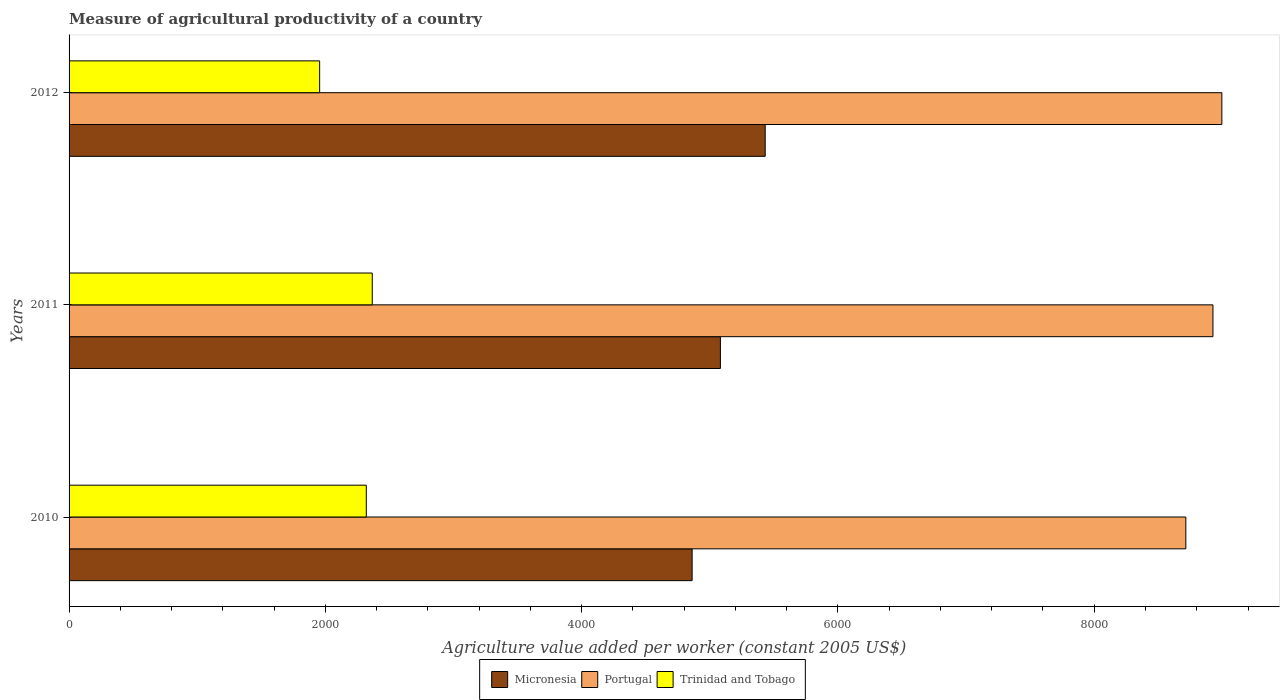How many groups of bars are there?
Your answer should be compact. 3. Are the number of bars on each tick of the Y-axis equal?
Your answer should be compact. Yes. How many bars are there on the 2nd tick from the bottom?
Your response must be concise. 3. What is the label of the 2nd group of bars from the top?
Give a very brief answer. 2011. In how many cases, is the number of bars for a given year not equal to the number of legend labels?
Offer a very short reply. 0. What is the measure of agricultural productivity in Trinidad and Tobago in 2011?
Ensure brevity in your answer.  2365.97. Across all years, what is the maximum measure of agricultural productivity in Portugal?
Ensure brevity in your answer.  8996.02. Across all years, what is the minimum measure of agricultural productivity in Micronesia?
Ensure brevity in your answer.  4862.14. What is the total measure of agricultural productivity in Portugal in the graph?
Provide a succinct answer. 2.66e+04. What is the difference between the measure of agricultural productivity in Trinidad and Tobago in 2010 and that in 2011?
Your response must be concise. -46.55. What is the difference between the measure of agricultural productivity in Trinidad and Tobago in 2010 and the measure of agricultural productivity in Portugal in 2011?
Give a very brief answer. -6607.09. What is the average measure of agricultural productivity in Micronesia per year?
Your response must be concise. 5125.77. In the year 2012, what is the difference between the measure of agricultural productivity in Trinidad and Tobago and measure of agricultural productivity in Portugal?
Your answer should be compact. -7040.59. In how many years, is the measure of agricultural productivity in Micronesia greater than 1200 US$?
Your answer should be compact. 3. What is the ratio of the measure of agricultural productivity in Portugal in 2011 to that in 2012?
Offer a very short reply. 0.99. Is the difference between the measure of agricultural productivity in Trinidad and Tobago in 2011 and 2012 greater than the difference between the measure of agricultural productivity in Portugal in 2011 and 2012?
Provide a succinct answer. Yes. What is the difference between the highest and the second highest measure of agricultural productivity in Portugal?
Make the answer very short. 69.5. What is the difference between the highest and the lowest measure of agricultural productivity in Micronesia?
Make the answer very short. 570.29. Is the sum of the measure of agricultural productivity in Micronesia in 2011 and 2012 greater than the maximum measure of agricultural productivity in Portugal across all years?
Provide a short and direct response. Yes. What does the 1st bar from the top in 2010 represents?
Your answer should be compact. Trinidad and Tobago. What does the 1st bar from the bottom in 2011 represents?
Your answer should be very brief. Micronesia. How many years are there in the graph?
Your answer should be very brief. 3. What is the difference between two consecutive major ticks on the X-axis?
Provide a short and direct response. 2000. Where does the legend appear in the graph?
Your response must be concise. Bottom center. How many legend labels are there?
Your response must be concise. 3. How are the legend labels stacked?
Offer a very short reply. Horizontal. What is the title of the graph?
Keep it short and to the point. Measure of agricultural productivity of a country. What is the label or title of the X-axis?
Keep it short and to the point. Agriculture value added per worker (constant 2005 US$). What is the label or title of the Y-axis?
Give a very brief answer. Years. What is the Agriculture value added per worker (constant 2005 US$) in Micronesia in 2010?
Provide a short and direct response. 4862.14. What is the Agriculture value added per worker (constant 2005 US$) in Portugal in 2010?
Provide a short and direct response. 8714.89. What is the Agriculture value added per worker (constant 2005 US$) in Trinidad and Tobago in 2010?
Offer a very short reply. 2319.42. What is the Agriculture value added per worker (constant 2005 US$) in Micronesia in 2011?
Keep it short and to the point. 5082.76. What is the Agriculture value added per worker (constant 2005 US$) of Portugal in 2011?
Your answer should be compact. 8926.51. What is the Agriculture value added per worker (constant 2005 US$) in Trinidad and Tobago in 2011?
Your answer should be compact. 2365.97. What is the Agriculture value added per worker (constant 2005 US$) of Micronesia in 2012?
Make the answer very short. 5432.42. What is the Agriculture value added per worker (constant 2005 US$) of Portugal in 2012?
Give a very brief answer. 8996.02. What is the Agriculture value added per worker (constant 2005 US$) in Trinidad and Tobago in 2012?
Offer a very short reply. 1955.42. Across all years, what is the maximum Agriculture value added per worker (constant 2005 US$) in Micronesia?
Keep it short and to the point. 5432.42. Across all years, what is the maximum Agriculture value added per worker (constant 2005 US$) in Portugal?
Your answer should be very brief. 8996.02. Across all years, what is the maximum Agriculture value added per worker (constant 2005 US$) of Trinidad and Tobago?
Give a very brief answer. 2365.97. Across all years, what is the minimum Agriculture value added per worker (constant 2005 US$) of Micronesia?
Your response must be concise. 4862.14. Across all years, what is the minimum Agriculture value added per worker (constant 2005 US$) of Portugal?
Provide a short and direct response. 8714.89. Across all years, what is the minimum Agriculture value added per worker (constant 2005 US$) in Trinidad and Tobago?
Offer a very short reply. 1955.42. What is the total Agriculture value added per worker (constant 2005 US$) in Micronesia in the graph?
Keep it short and to the point. 1.54e+04. What is the total Agriculture value added per worker (constant 2005 US$) of Portugal in the graph?
Provide a short and direct response. 2.66e+04. What is the total Agriculture value added per worker (constant 2005 US$) of Trinidad and Tobago in the graph?
Your answer should be very brief. 6640.82. What is the difference between the Agriculture value added per worker (constant 2005 US$) in Micronesia in 2010 and that in 2011?
Make the answer very short. -220.62. What is the difference between the Agriculture value added per worker (constant 2005 US$) of Portugal in 2010 and that in 2011?
Make the answer very short. -211.62. What is the difference between the Agriculture value added per worker (constant 2005 US$) of Trinidad and Tobago in 2010 and that in 2011?
Ensure brevity in your answer.  -46.55. What is the difference between the Agriculture value added per worker (constant 2005 US$) in Micronesia in 2010 and that in 2012?
Keep it short and to the point. -570.29. What is the difference between the Agriculture value added per worker (constant 2005 US$) of Portugal in 2010 and that in 2012?
Ensure brevity in your answer.  -281.13. What is the difference between the Agriculture value added per worker (constant 2005 US$) of Trinidad and Tobago in 2010 and that in 2012?
Your answer should be compact. 364. What is the difference between the Agriculture value added per worker (constant 2005 US$) in Micronesia in 2011 and that in 2012?
Your answer should be very brief. -349.67. What is the difference between the Agriculture value added per worker (constant 2005 US$) of Portugal in 2011 and that in 2012?
Make the answer very short. -69.5. What is the difference between the Agriculture value added per worker (constant 2005 US$) of Trinidad and Tobago in 2011 and that in 2012?
Your answer should be very brief. 410.55. What is the difference between the Agriculture value added per worker (constant 2005 US$) in Micronesia in 2010 and the Agriculture value added per worker (constant 2005 US$) in Portugal in 2011?
Your response must be concise. -4064.38. What is the difference between the Agriculture value added per worker (constant 2005 US$) of Micronesia in 2010 and the Agriculture value added per worker (constant 2005 US$) of Trinidad and Tobago in 2011?
Provide a short and direct response. 2496.16. What is the difference between the Agriculture value added per worker (constant 2005 US$) in Portugal in 2010 and the Agriculture value added per worker (constant 2005 US$) in Trinidad and Tobago in 2011?
Provide a short and direct response. 6348.92. What is the difference between the Agriculture value added per worker (constant 2005 US$) in Micronesia in 2010 and the Agriculture value added per worker (constant 2005 US$) in Portugal in 2012?
Keep it short and to the point. -4133.88. What is the difference between the Agriculture value added per worker (constant 2005 US$) of Micronesia in 2010 and the Agriculture value added per worker (constant 2005 US$) of Trinidad and Tobago in 2012?
Your answer should be very brief. 2906.71. What is the difference between the Agriculture value added per worker (constant 2005 US$) of Portugal in 2010 and the Agriculture value added per worker (constant 2005 US$) of Trinidad and Tobago in 2012?
Give a very brief answer. 6759.47. What is the difference between the Agriculture value added per worker (constant 2005 US$) of Micronesia in 2011 and the Agriculture value added per worker (constant 2005 US$) of Portugal in 2012?
Make the answer very short. -3913.26. What is the difference between the Agriculture value added per worker (constant 2005 US$) in Micronesia in 2011 and the Agriculture value added per worker (constant 2005 US$) in Trinidad and Tobago in 2012?
Give a very brief answer. 3127.33. What is the difference between the Agriculture value added per worker (constant 2005 US$) in Portugal in 2011 and the Agriculture value added per worker (constant 2005 US$) in Trinidad and Tobago in 2012?
Provide a succinct answer. 6971.09. What is the average Agriculture value added per worker (constant 2005 US$) of Micronesia per year?
Your response must be concise. 5125.77. What is the average Agriculture value added per worker (constant 2005 US$) in Portugal per year?
Ensure brevity in your answer.  8879.14. What is the average Agriculture value added per worker (constant 2005 US$) in Trinidad and Tobago per year?
Provide a short and direct response. 2213.61. In the year 2010, what is the difference between the Agriculture value added per worker (constant 2005 US$) of Micronesia and Agriculture value added per worker (constant 2005 US$) of Portugal?
Your answer should be compact. -3852.75. In the year 2010, what is the difference between the Agriculture value added per worker (constant 2005 US$) of Micronesia and Agriculture value added per worker (constant 2005 US$) of Trinidad and Tobago?
Offer a very short reply. 2542.71. In the year 2010, what is the difference between the Agriculture value added per worker (constant 2005 US$) of Portugal and Agriculture value added per worker (constant 2005 US$) of Trinidad and Tobago?
Your response must be concise. 6395.47. In the year 2011, what is the difference between the Agriculture value added per worker (constant 2005 US$) of Micronesia and Agriculture value added per worker (constant 2005 US$) of Portugal?
Make the answer very short. -3843.76. In the year 2011, what is the difference between the Agriculture value added per worker (constant 2005 US$) of Micronesia and Agriculture value added per worker (constant 2005 US$) of Trinidad and Tobago?
Keep it short and to the point. 2716.78. In the year 2011, what is the difference between the Agriculture value added per worker (constant 2005 US$) of Portugal and Agriculture value added per worker (constant 2005 US$) of Trinidad and Tobago?
Provide a short and direct response. 6560.54. In the year 2012, what is the difference between the Agriculture value added per worker (constant 2005 US$) of Micronesia and Agriculture value added per worker (constant 2005 US$) of Portugal?
Offer a very short reply. -3563.59. In the year 2012, what is the difference between the Agriculture value added per worker (constant 2005 US$) of Micronesia and Agriculture value added per worker (constant 2005 US$) of Trinidad and Tobago?
Your answer should be compact. 3477. In the year 2012, what is the difference between the Agriculture value added per worker (constant 2005 US$) in Portugal and Agriculture value added per worker (constant 2005 US$) in Trinidad and Tobago?
Your response must be concise. 7040.59. What is the ratio of the Agriculture value added per worker (constant 2005 US$) in Micronesia in 2010 to that in 2011?
Ensure brevity in your answer.  0.96. What is the ratio of the Agriculture value added per worker (constant 2005 US$) in Portugal in 2010 to that in 2011?
Provide a short and direct response. 0.98. What is the ratio of the Agriculture value added per worker (constant 2005 US$) in Trinidad and Tobago in 2010 to that in 2011?
Provide a short and direct response. 0.98. What is the ratio of the Agriculture value added per worker (constant 2005 US$) of Micronesia in 2010 to that in 2012?
Your answer should be very brief. 0.9. What is the ratio of the Agriculture value added per worker (constant 2005 US$) in Portugal in 2010 to that in 2012?
Keep it short and to the point. 0.97. What is the ratio of the Agriculture value added per worker (constant 2005 US$) in Trinidad and Tobago in 2010 to that in 2012?
Your answer should be compact. 1.19. What is the ratio of the Agriculture value added per worker (constant 2005 US$) of Micronesia in 2011 to that in 2012?
Provide a short and direct response. 0.94. What is the ratio of the Agriculture value added per worker (constant 2005 US$) in Portugal in 2011 to that in 2012?
Offer a terse response. 0.99. What is the ratio of the Agriculture value added per worker (constant 2005 US$) of Trinidad and Tobago in 2011 to that in 2012?
Provide a short and direct response. 1.21. What is the difference between the highest and the second highest Agriculture value added per worker (constant 2005 US$) in Micronesia?
Offer a terse response. 349.67. What is the difference between the highest and the second highest Agriculture value added per worker (constant 2005 US$) in Portugal?
Offer a terse response. 69.5. What is the difference between the highest and the second highest Agriculture value added per worker (constant 2005 US$) of Trinidad and Tobago?
Your answer should be very brief. 46.55. What is the difference between the highest and the lowest Agriculture value added per worker (constant 2005 US$) of Micronesia?
Offer a very short reply. 570.29. What is the difference between the highest and the lowest Agriculture value added per worker (constant 2005 US$) in Portugal?
Offer a very short reply. 281.13. What is the difference between the highest and the lowest Agriculture value added per worker (constant 2005 US$) of Trinidad and Tobago?
Provide a succinct answer. 410.55. 